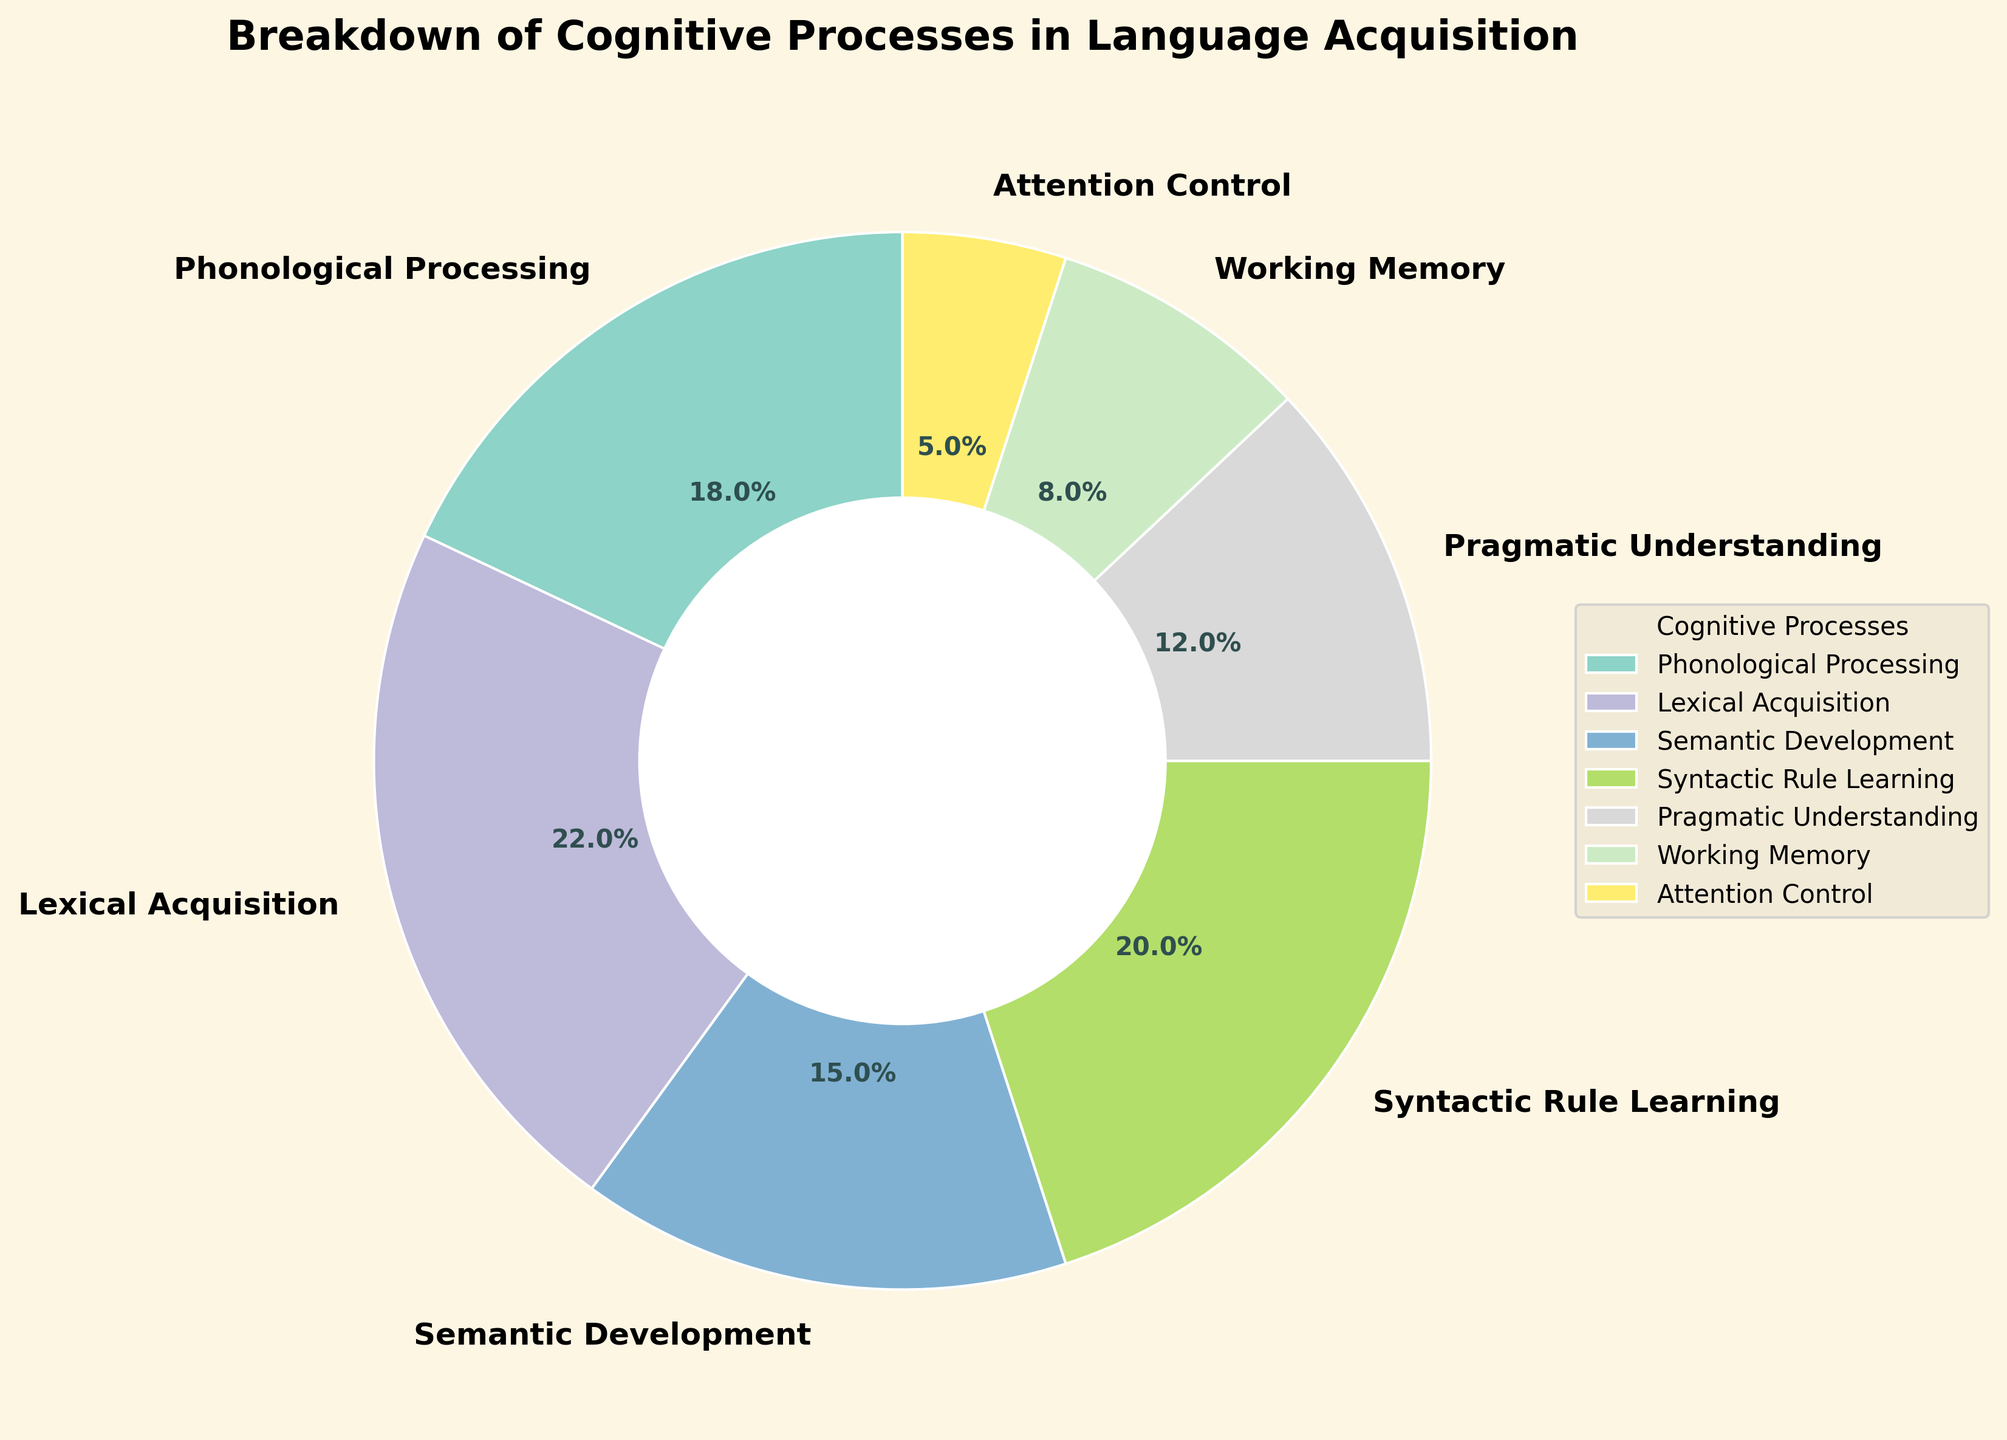How much larger is the percentage of Lexical Acquisition compared to Working Memory? Lexical Acquisition is 22% and Working Memory is 8%. The difference between them is 22% - 8% = 14%.
Answer: 14% Which cognitive process has the smallest percentage? By examining the chart, Attention Control has the smallest percentage at 5%.
Answer: Attention Control What is the combined percentage of Phonological Processing and Semantic Development? Phonological Processing is 18% and Semantic Development is 15%. Adding them together, 18% + 15% = 33%.
Answer: 33% Which cognitive process has a greater percentage: Syntactic Rule Learning or Pragmatic Understanding? Syntactic Rule Learning has 20% and Pragmatic Understanding has 12%. 20% is greater than 12%.
Answer: Syntactic Rule Learning What percentage of the cognitive processes involve Syntactic Rule Learning and Working Memory combined? Syntactic Rule Learning is 20% and Working Memory is 8%. Adding them together, you get 20% + 8% = 28%.
Answer: 28% Identify the cognitive processes that have a percentage greater than 15% and less than 25%. Lexical Acquisition is 22%, Syntactic Rule Learning is 20%, and Phonological Processing is 18%. These are greater than 15% and less than 25%.
Answer: Lexical Acquisition, Syntactic Rule Learning, Phonological Processing Is the sum of Phonological Processing and Attention Control's percentages larger than Lexical Acquisition's percentage? Phonological Processing is 18% and Attention Control is 5%. Adding these, 18% + 5% = 23%. Lexical Acquisition is 22%, so 23% is larger than 22%.
Answer: Yes Which cognitive process has a percentage twice as large as Attention Control? Attention Control is 5%. Twice this is 5% * 2 = 10%. No cognitive process in the chart has exactly 10%, but close to it is Working Memory at 8%, which is less and Lexical Acquisition at 22%, which is not twice.
Answer: None What percentage of the total is accounted for by the three processes with the smallest percentages? The three smallest percentages are Working Memory at 8%, Attention Control at 5%, and Pragmatic Understanding at 12%. Adding these, 8% + 5% + 12% = 25%.
Answer: 25% How much more is the percentage of Lexical Acquisition than the median percentage of all processes? To find the median, order the percentages: 5%, 8%, 12%, 15%, 18%, 20%, 22%. The median is 15%. Lexical Acquisition is 22%. The difference is 22% - 15% = 7%.
Answer: 7% 